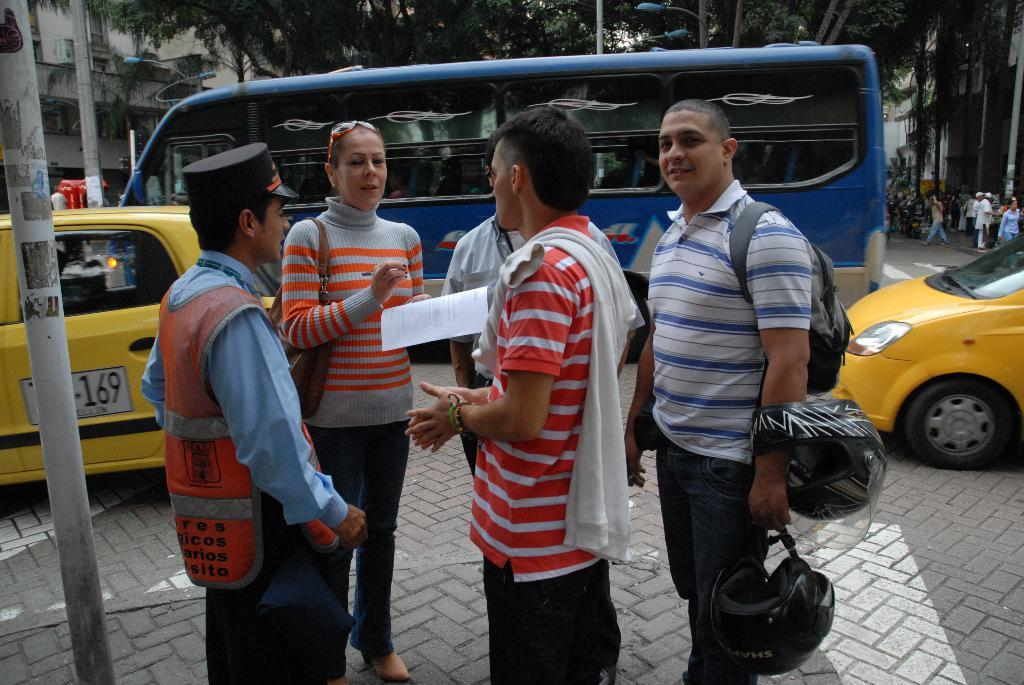What is happening in the image? There are people standing in the image. Can you describe the items held by the people? One person is holding helmets and wearing a bag, while another person is holding papers and a pen. What else can be seen in the image? There are poles, vehicles, people, and buildings in the background. What type of sticks are being used to harvest the cabbage in the image? There is no cabbage or sticks present in the image. How many bikes are visible in the image? There are no bikes visible in the image. 